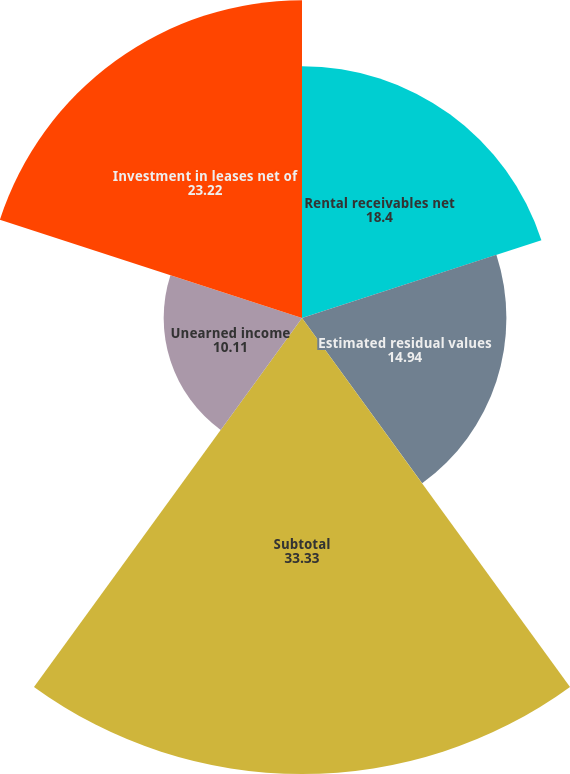Convert chart. <chart><loc_0><loc_0><loc_500><loc_500><pie_chart><fcel>Rental receivables net<fcel>Estimated residual values<fcel>Subtotal<fcel>Unearned income<fcel>Investment in leases net of<nl><fcel>18.4%<fcel>14.94%<fcel>33.33%<fcel>10.11%<fcel>23.22%<nl></chart> 